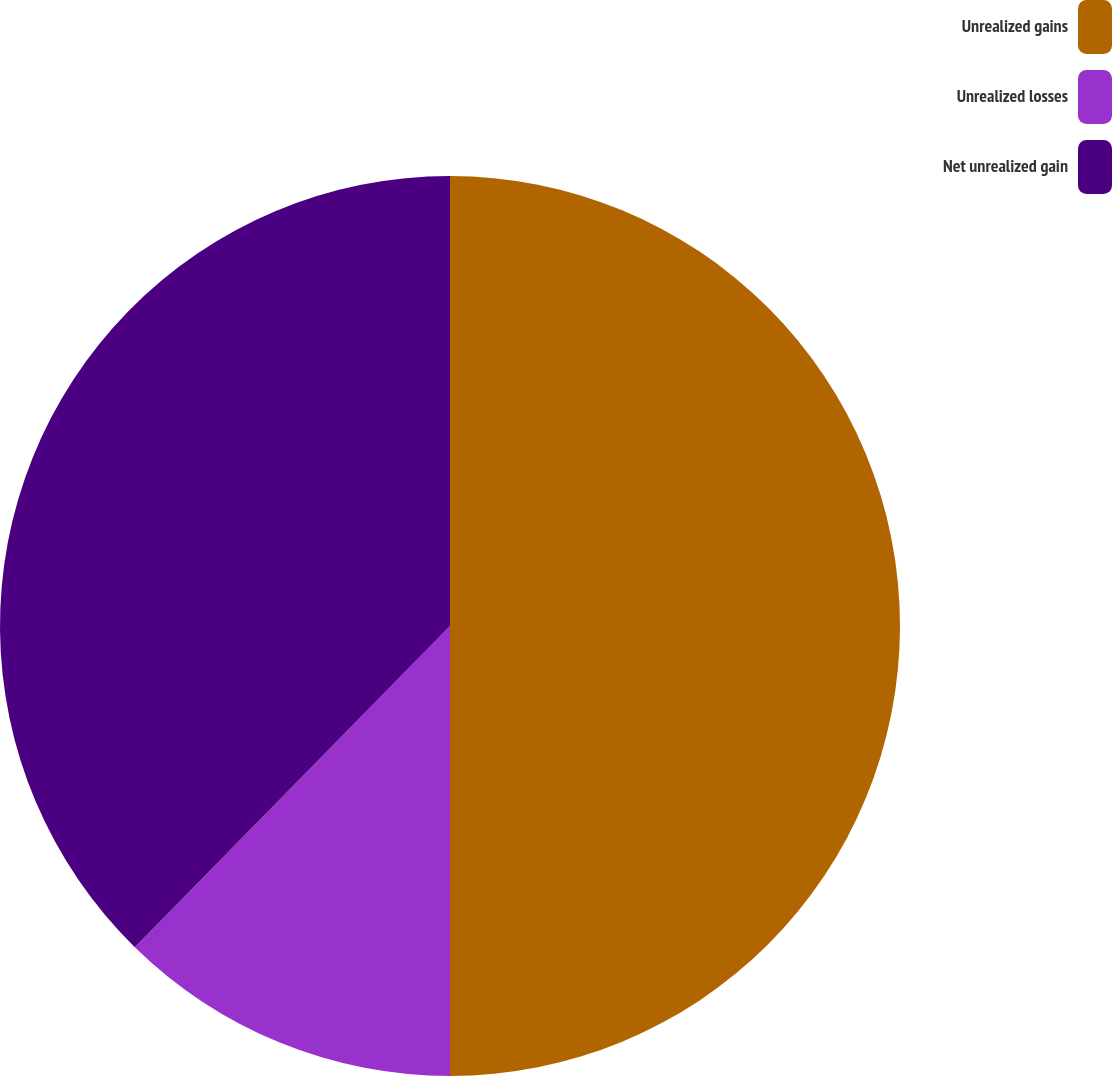Convert chart. <chart><loc_0><loc_0><loc_500><loc_500><pie_chart><fcel>Unrealized gains<fcel>Unrealized losses<fcel>Net unrealized gain<nl><fcel>50.0%<fcel>12.35%<fcel>37.65%<nl></chart> 